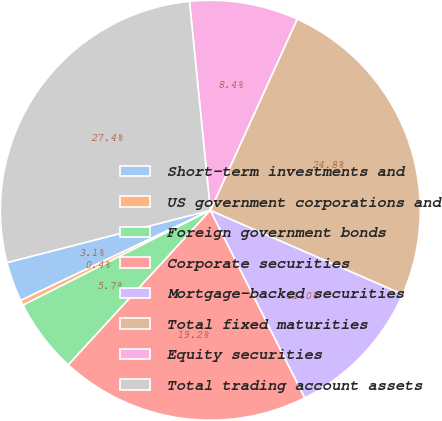<chart> <loc_0><loc_0><loc_500><loc_500><pie_chart><fcel>Short-term investments and<fcel>US government corporations and<fcel>Foreign government bonds<fcel>Corporate securities<fcel>Mortgage-backed securities<fcel>Total fixed maturities<fcel>Equity securities<fcel>Total trading account assets<nl><fcel>3.06%<fcel>0.4%<fcel>5.71%<fcel>19.25%<fcel>11.02%<fcel>24.77%<fcel>8.37%<fcel>27.42%<nl></chart> 